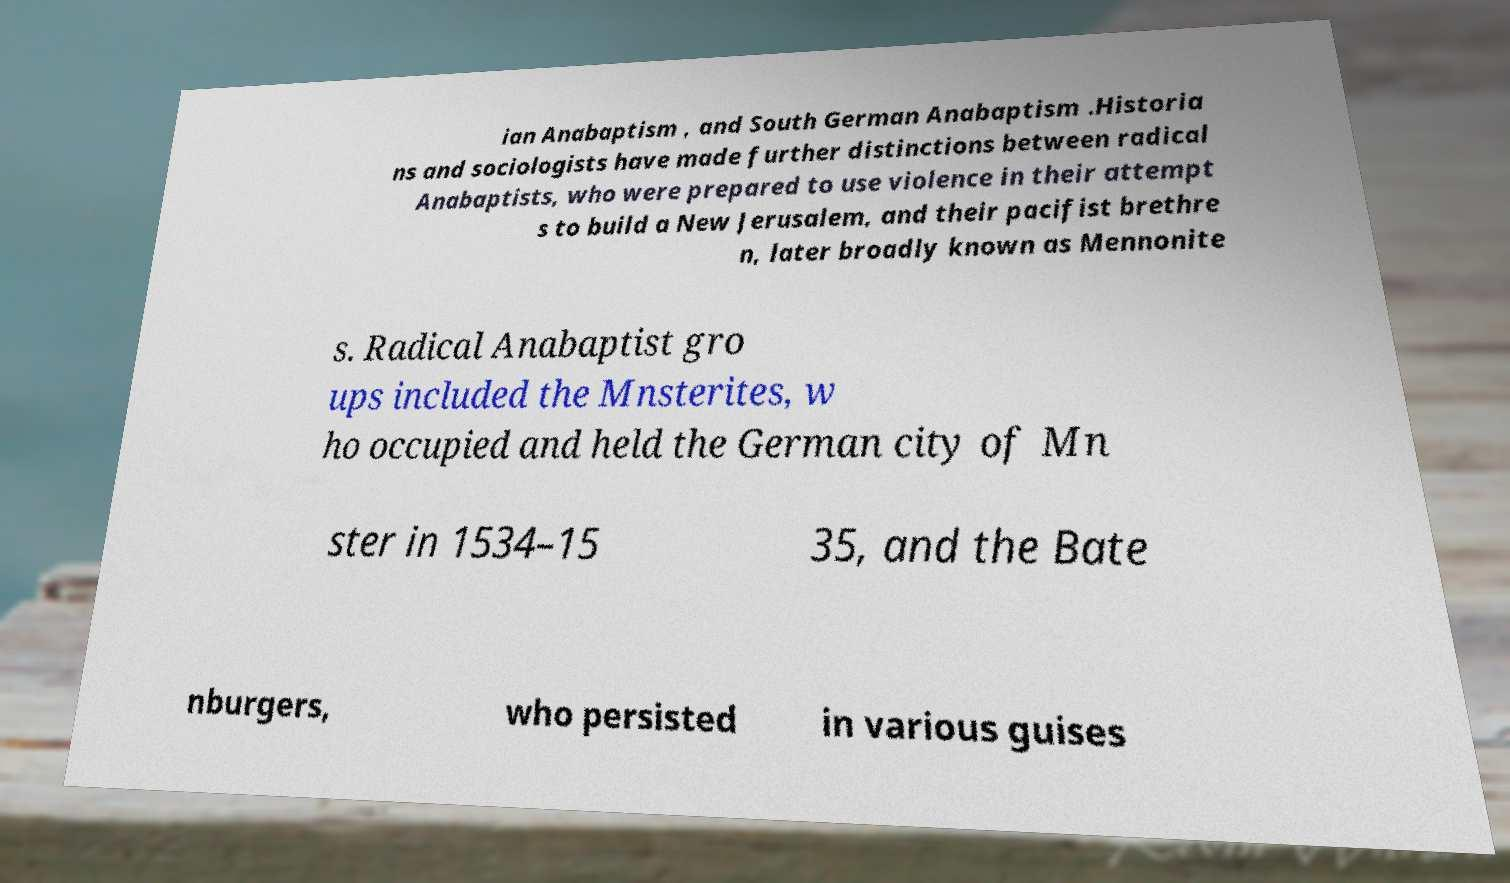What messages or text are displayed in this image? I need them in a readable, typed format. ian Anabaptism , and South German Anabaptism .Historia ns and sociologists have made further distinctions between radical Anabaptists, who were prepared to use violence in their attempt s to build a New Jerusalem, and their pacifist brethre n, later broadly known as Mennonite s. Radical Anabaptist gro ups included the Mnsterites, w ho occupied and held the German city of Mn ster in 1534–15 35, and the Bate nburgers, who persisted in various guises 